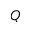Convert formula to latex. <formula><loc_0><loc_0><loc_500><loc_500>Q</formula> 